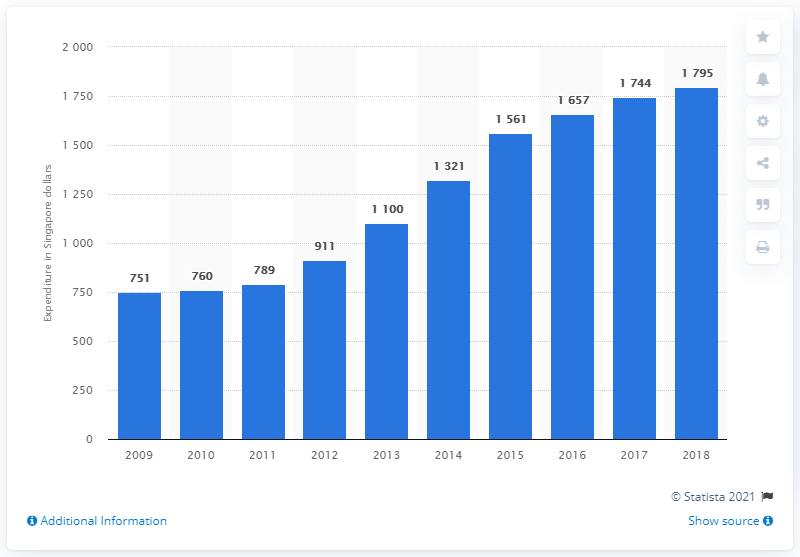Outline some significant characteristics in this image. In 2018, the Singapore government spent an average of 1,795 dollars per resident on health-related expenditures. 